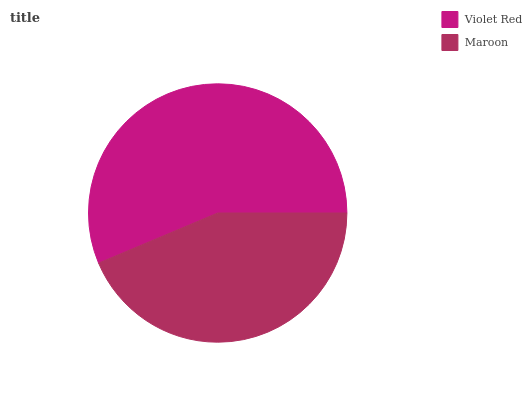Is Maroon the minimum?
Answer yes or no. Yes. Is Violet Red the maximum?
Answer yes or no. Yes. Is Maroon the maximum?
Answer yes or no. No. Is Violet Red greater than Maroon?
Answer yes or no. Yes. Is Maroon less than Violet Red?
Answer yes or no. Yes. Is Maroon greater than Violet Red?
Answer yes or no. No. Is Violet Red less than Maroon?
Answer yes or no. No. Is Violet Red the high median?
Answer yes or no. Yes. Is Maroon the low median?
Answer yes or no. Yes. Is Maroon the high median?
Answer yes or no. No. Is Violet Red the low median?
Answer yes or no. No. 